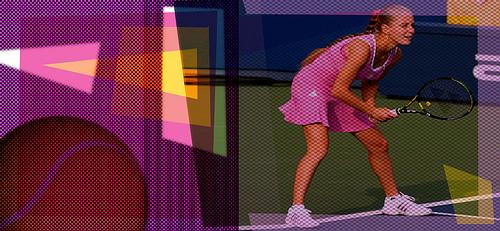What color outfit is the woman wearing?
Concise answer only. Pink. What brand of sneakers is the person wearing in the photo?
Answer briefly. Adidas. Why does this photo appear grainy?
Answer briefly. Net. 